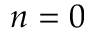<formula> <loc_0><loc_0><loc_500><loc_500>n = 0</formula> 